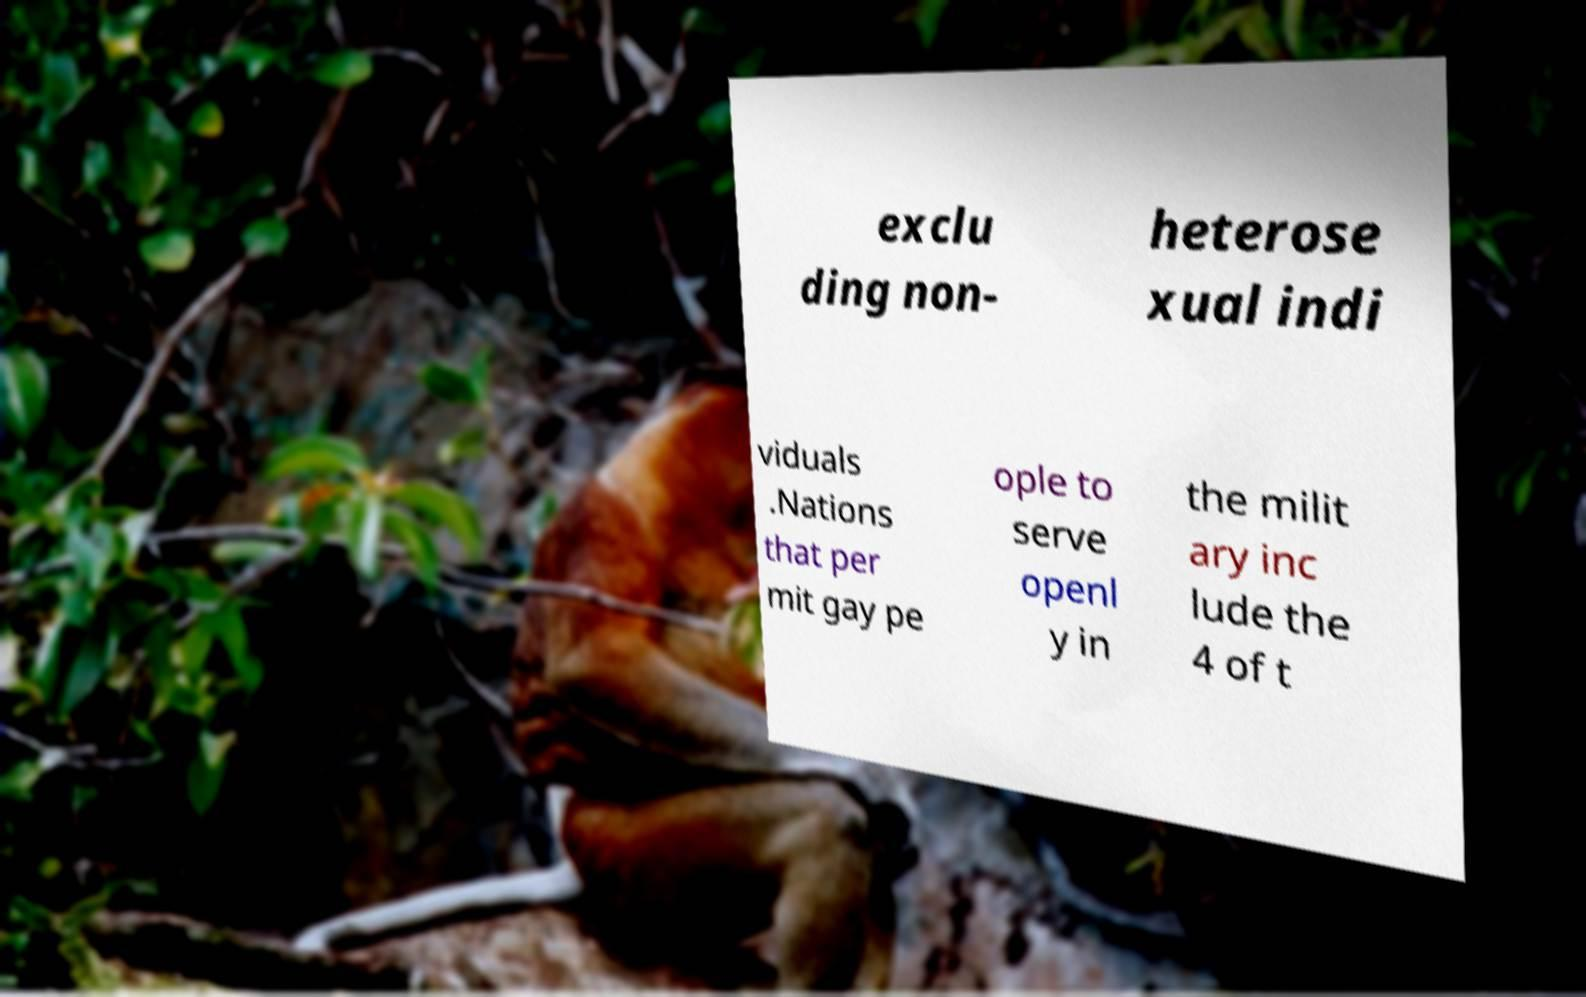Could you extract and type out the text from this image? exclu ding non- heterose xual indi viduals .Nations that per mit gay pe ople to serve openl y in the milit ary inc lude the 4 of t 